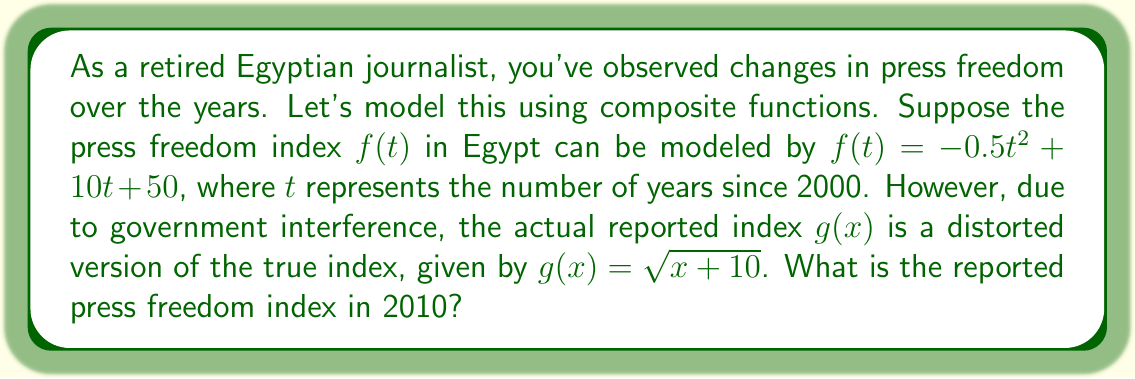Provide a solution to this math problem. To solve this problem, we need to use function composition. We'll follow these steps:

1) First, we need to find $f(10)$, as 2010 is 10 years after 2000.

   $f(10) = -0.5(10)^2 + 10(10) + 50$
   $= -0.5(100) + 100 + 50$
   $= -50 + 100 + 50$
   $= 100$

2) Now, we need to apply the distortion function $g$ to this result:

   $g(f(10)) = g(100)$

3) We can now calculate $g(100)$:

   $g(100) = \sqrt{100+10} = \sqrt{110}$

4) Simplify:
   
   $\sqrt{110} \approx 10.49$

Therefore, the reported press freedom index in 2010 is approximately 10.49.
Answer: $g(f(10)) = \sqrt{110} \approx 10.49$ 